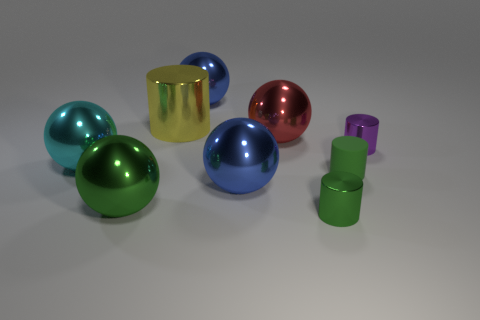Subtract all yellow cylinders. How many cylinders are left? 3 Subtract all cyan spheres. How many green cylinders are left? 2 Add 1 tiny yellow objects. How many objects exist? 10 Subtract all green cylinders. How many cylinders are left? 2 Subtract all spheres. How many objects are left? 4 Subtract all gray cylinders. Subtract all blue balls. How many cylinders are left? 4 Add 3 tiny purple things. How many tiny purple things are left? 4 Add 4 big green spheres. How many big green spheres exist? 5 Subtract 0 gray balls. How many objects are left? 9 Subtract all tiny rubber things. Subtract all small green matte cylinders. How many objects are left? 7 